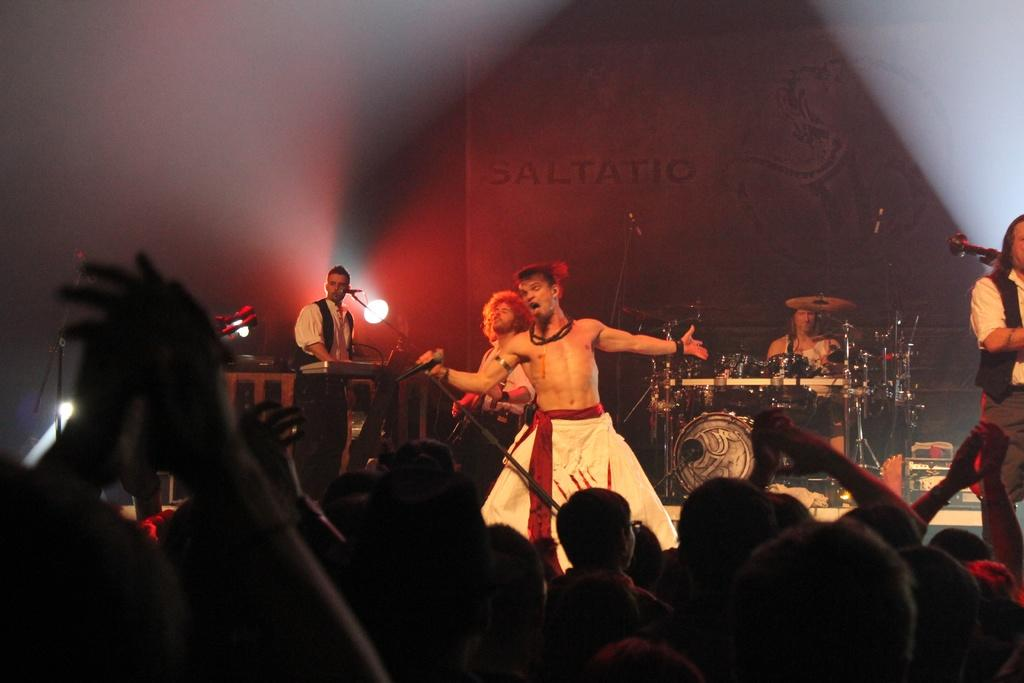How many people are playing musical instruments in the image? There are three people playing musical instruments in the image. What is the man holding while he is singing? The man is holding a mic while he is singing. Can you describe any additional equipment in the image? Yes, there is a focusing light visible in the image. Are there any spectators in the image? Yes, there are people in the audience. How many geese are jumping in the image? There are no geese or jumping actions depicted in the image. 